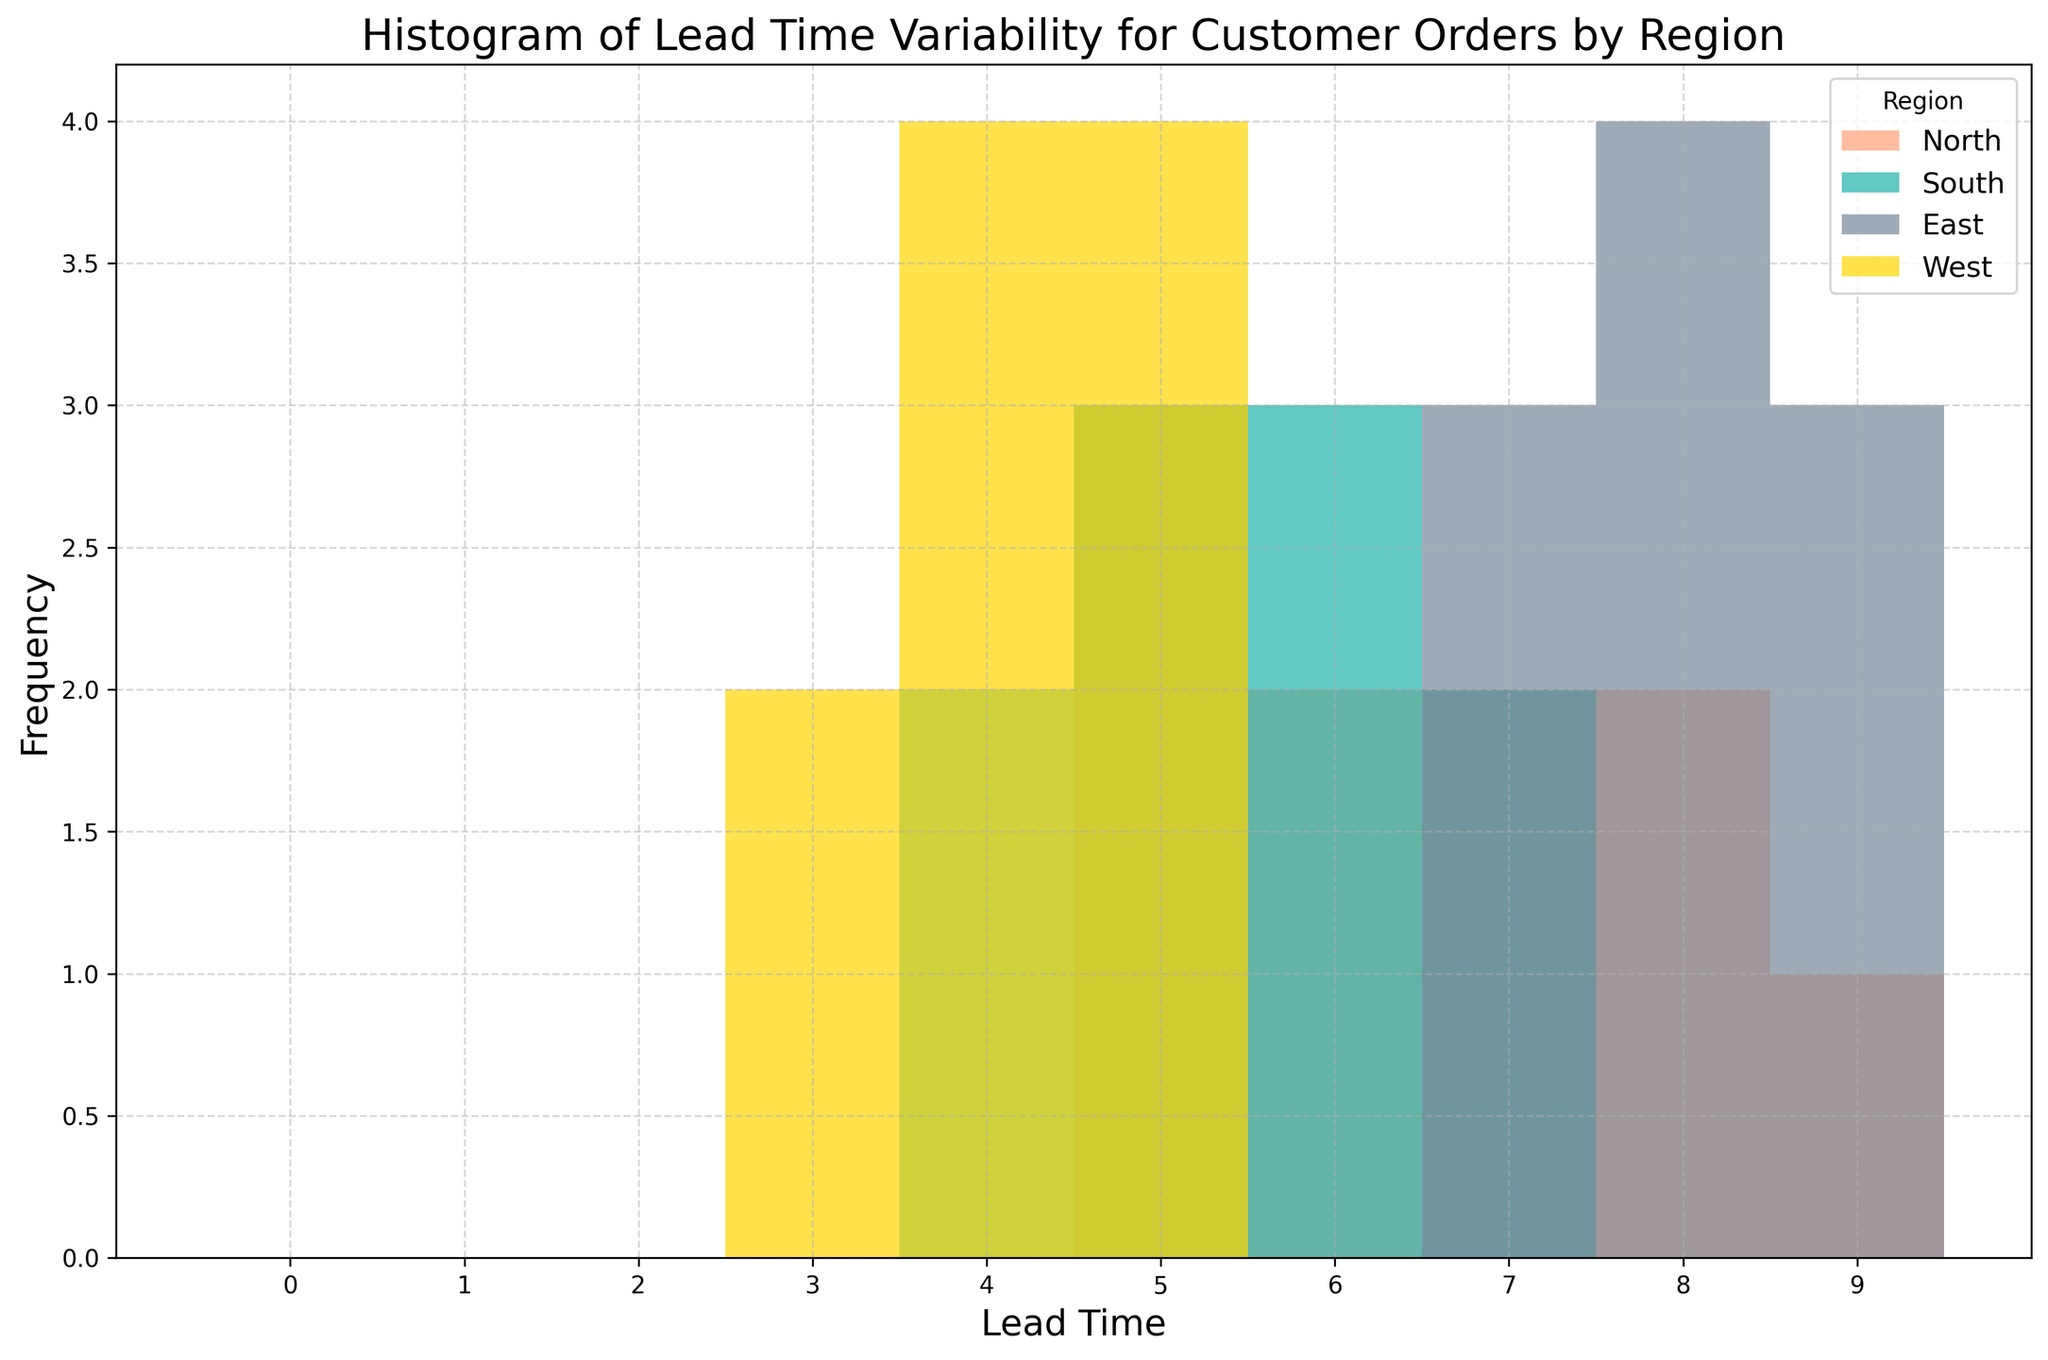what is the range of lead times for the North region? To find the range, we subtract the smallest value from the largest value in the North region. The smallest is 5, and the largest is 9. Therefore, the range is 9 - 5.
Answer: 4 which region has the highest frequency of the shortest lead time? By observing the bars representing lead times, the region with the highest frequency at the shortest lead time(3) is the West region.
Answer: West what are the average lead times for the East and South regions? For the East region, sum all lead times (8+9+8+7+8+9+7+8+9+7=80) and divide by the number of data points (10). For the South region, sum all lead times (4+6+5+7+5+6+4+7+5+6=55) and divide by the number of data points (10). Average lead time for the East is 8, and for the South is 5.5.
Answer: East: 8, South: 5.5 which region has the most consistent lead times? By looking at the spread and height of the bars, the West region has the most consistent lead times, clustered mostly around lead times 3, 4, and 5.
Answer: West how does the distribution of lead times in the North region compare to the distribution in the East region? The North region has a lead time range from 5 to 9 with more uniform distribution, while the East region has a very consistent distribution clustered closely around 7, 8, and 9. The East has fewer unique values but more frequency at higher lead times.
Answer: North: more scattered, East: more clustered what is the combined frequency of lead times 7 and 8 in the East region? In the East region, count the occurrences of lead times 7 and 8. Lead time 7 appears 3 times, and lead time 8 appears 4 times. Combined frequency is 3+4.
Answer: 7 which region has the least variability in lead times? The West region has the smallest range of lead times (from 3 to 5), indicating the least variability compared to other regions.
Answer: West how do the highest frequencies of the North and South regions compare? The highest frequency for the North region occurs at lead time 6 and 7. The highest frequency for the South region occurs at lead time 5 and 6. Comparing their heights, North is more frequent at lead time 7, and South has almost equal frequency at lead time 5 and 6.
Answer: North: 7, South: 5/6, nearly equal 